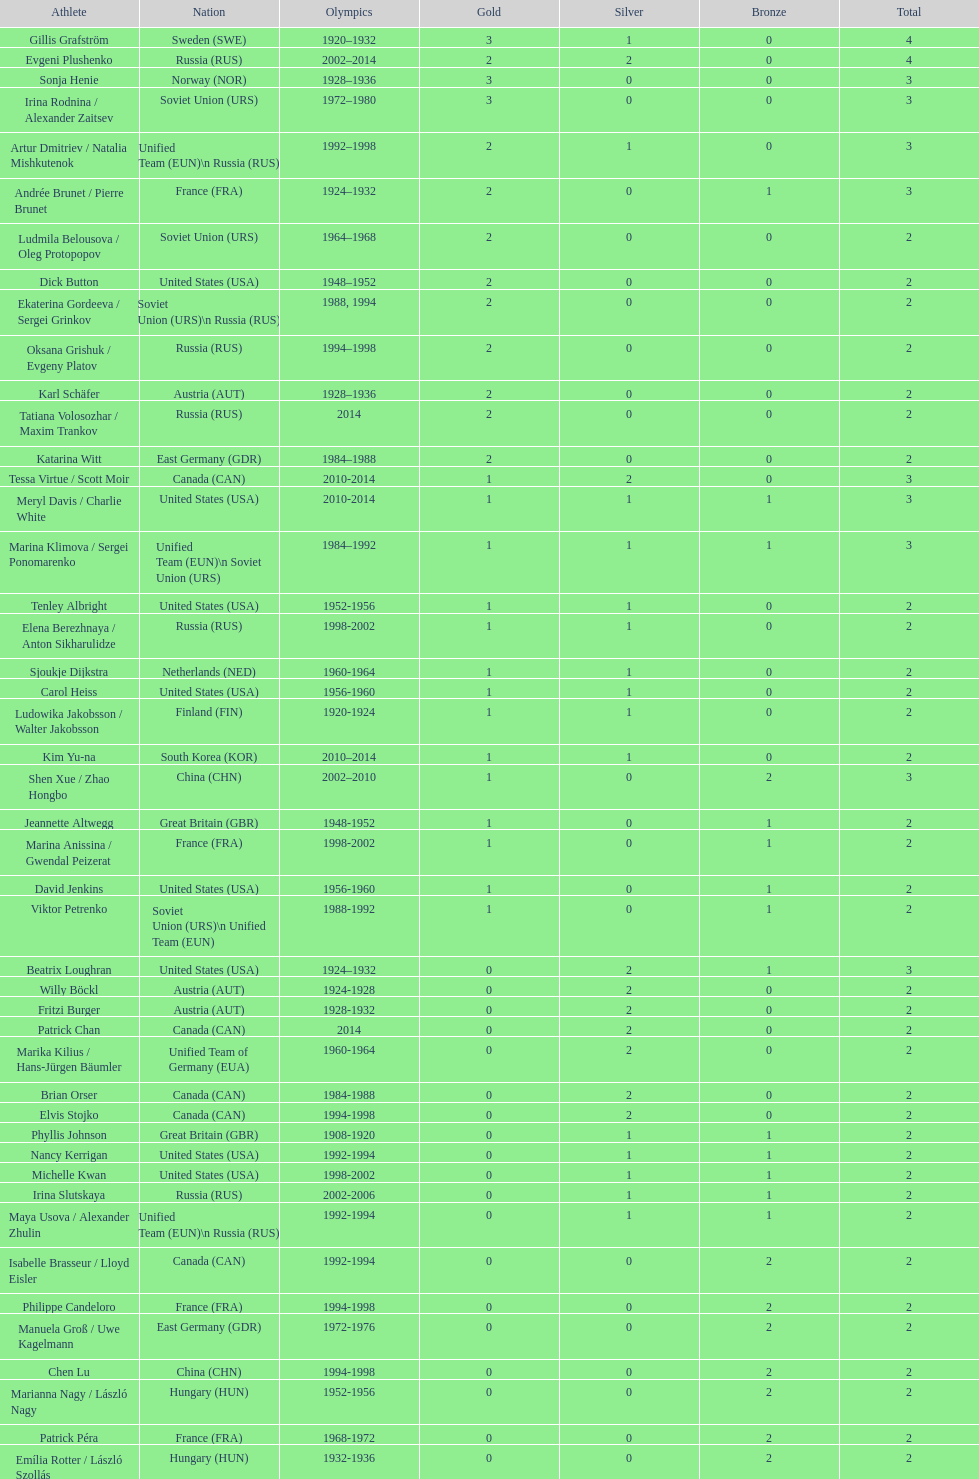What is the sum of medals won by sweden and norway together? 7. 